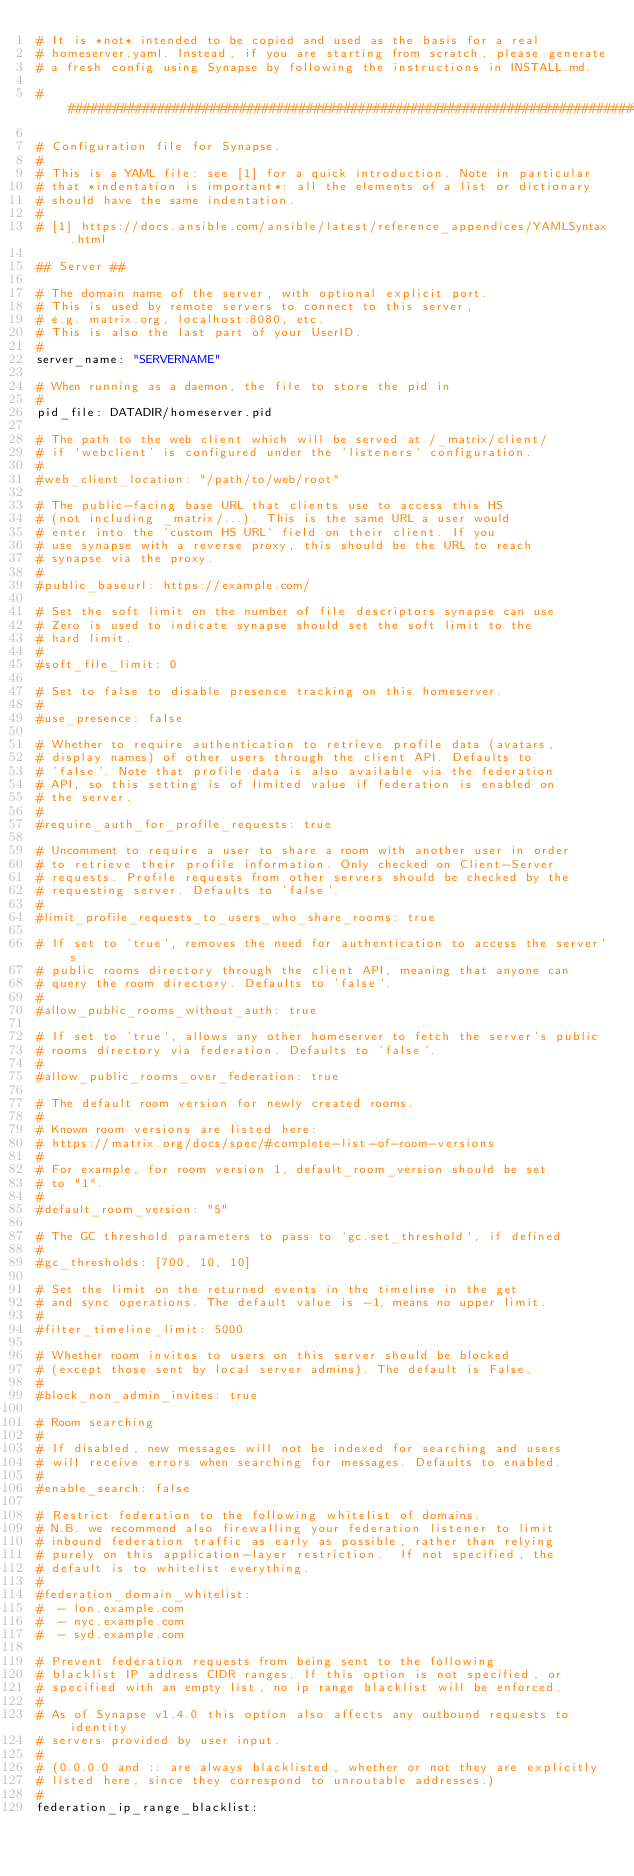<code> <loc_0><loc_0><loc_500><loc_500><_YAML_># It is *not* intended to be copied and used as the basis for a real
# homeserver.yaml. Instead, if you are starting from scratch, please generate
# a fresh config using Synapse by following the instructions in INSTALL.md.

################################################################################

# Configuration file for Synapse.
#
# This is a YAML file: see [1] for a quick introduction. Note in particular
# that *indentation is important*: all the elements of a list or dictionary
# should have the same indentation.
#
# [1] https://docs.ansible.com/ansible/latest/reference_appendices/YAMLSyntax.html

## Server ##

# The domain name of the server, with optional explicit port.
# This is used by remote servers to connect to this server,
# e.g. matrix.org, localhost:8080, etc.
# This is also the last part of your UserID.
#
server_name: "SERVERNAME"

# When running as a daemon, the file to store the pid in
#
pid_file: DATADIR/homeserver.pid

# The path to the web client which will be served at /_matrix/client/
# if 'webclient' is configured under the 'listeners' configuration.
#
#web_client_location: "/path/to/web/root"

# The public-facing base URL that clients use to access this HS
# (not including _matrix/...). This is the same URL a user would
# enter into the 'custom HS URL' field on their client. If you
# use synapse with a reverse proxy, this should be the URL to reach
# synapse via the proxy.
#
#public_baseurl: https://example.com/

# Set the soft limit on the number of file descriptors synapse can use
# Zero is used to indicate synapse should set the soft limit to the
# hard limit.
#
#soft_file_limit: 0

# Set to false to disable presence tracking on this homeserver.
#
#use_presence: false

# Whether to require authentication to retrieve profile data (avatars,
# display names) of other users through the client API. Defaults to
# 'false'. Note that profile data is also available via the federation
# API, so this setting is of limited value if federation is enabled on
# the server.
#
#require_auth_for_profile_requests: true

# Uncomment to require a user to share a room with another user in order
# to retrieve their profile information. Only checked on Client-Server
# requests. Profile requests from other servers should be checked by the
# requesting server. Defaults to 'false'.
#
#limit_profile_requests_to_users_who_share_rooms: true

# If set to 'true', removes the need for authentication to access the server's
# public rooms directory through the client API, meaning that anyone can
# query the room directory. Defaults to 'false'.
#
#allow_public_rooms_without_auth: true

# If set to 'true', allows any other homeserver to fetch the server's public
# rooms directory via federation. Defaults to 'false'.
#
#allow_public_rooms_over_federation: true

# The default room version for newly created rooms.
#
# Known room versions are listed here:
# https://matrix.org/docs/spec/#complete-list-of-room-versions
#
# For example, for room version 1, default_room_version should be set
# to "1".
#
#default_room_version: "5"

# The GC threshold parameters to pass to `gc.set_threshold`, if defined
#
#gc_thresholds: [700, 10, 10]

# Set the limit on the returned events in the timeline in the get
# and sync operations. The default value is -1, means no upper limit.
#
#filter_timeline_limit: 5000

# Whether room invites to users on this server should be blocked
# (except those sent by local server admins). The default is False.
#
#block_non_admin_invites: true

# Room searching
#
# If disabled, new messages will not be indexed for searching and users
# will receive errors when searching for messages. Defaults to enabled.
#
#enable_search: false

# Restrict federation to the following whitelist of domains.
# N.B. we recommend also firewalling your federation listener to limit
# inbound federation traffic as early as possible, rather than relying
# purely on this application-layer restriction.  If not specified, the
# default is to whitelist everything.
#
#federation_domain_whitelist:
#  - lon.example.com
#  - nyc.example.com
#  - syd.example.com

# Prevent federation requests from being sent to the following
# blacklist IP address CIDR ranges. If this option is not specified, or
# specified with an empty list, no ip range blacklist will be enforced.
#
# As of Synapse v1.4.0 this option also affects any outbound requests to identity
# servers provided by user input.
#
# (0.0.0.0 and :: are always blacklisted, whether or not they are explicitly
# listed here, since they correspond to unroutable addresses.)
#
federation_ip_range_blacklist:</code> 